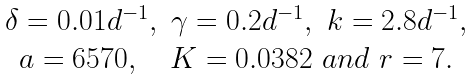<formula> <loc_0><loc_0><loc_500><loc_500>\begin{array} { c } \delta = 0 . 0 1 d ^ { - 1 } , \ \gamma = 0 . 2 d ^ { - 1 } , \ k = 2 . 8 d ^ { - 1 } , \\ a = 6 5 7 0 , \quad K = 0 . 0 3 8 2 \ a n d \ r = 7 . \end{array}</formula> 